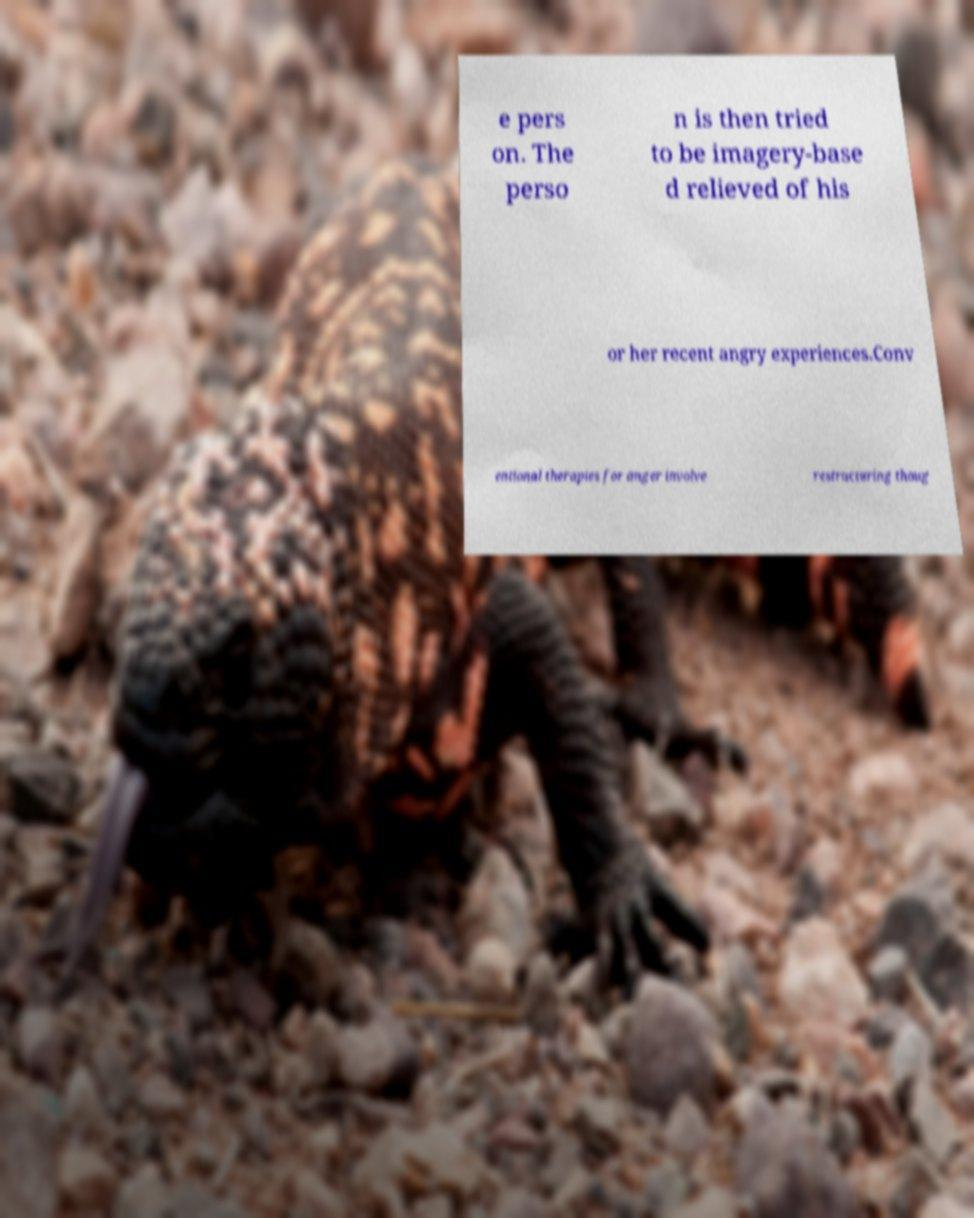Could you extract and type out the text from this image? e pers on. The perso n is then tried to be imagery-base d relieved of his or her recent angry experiences.Conv entional therapies for anger involve restructuring thoug 